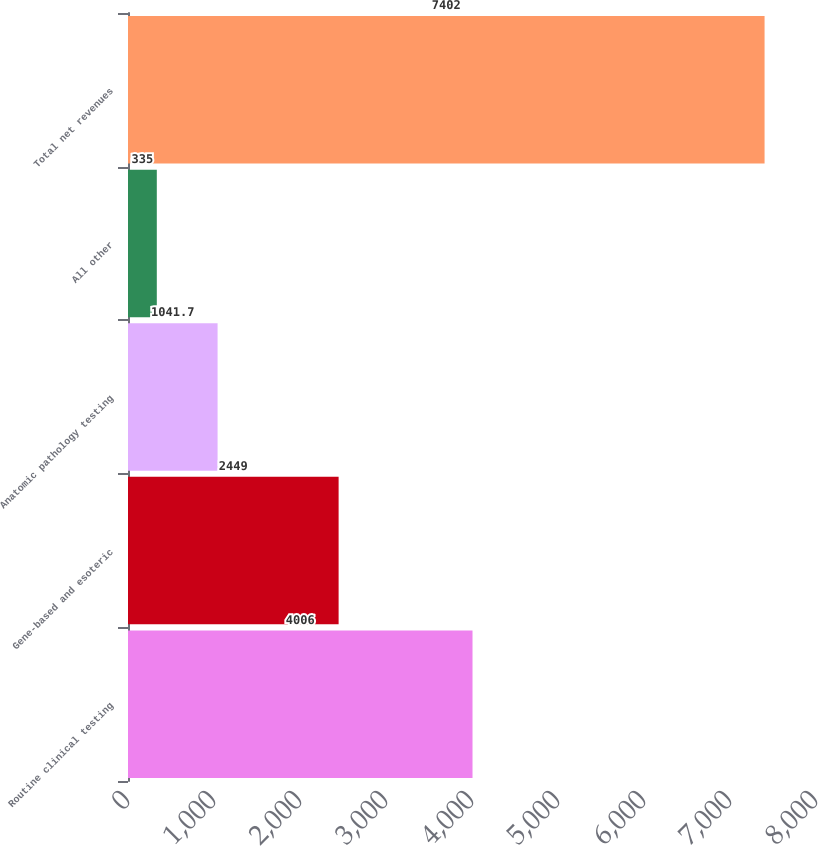<chart> <loc_0><loc_0><loc_500><loc_500><bar_chart><fcel>Routine clinical testing<fcel>Gene-based and esoteric<fcel>Anatomic pathology testing<fcel>All other<fcel>Total net revenues<nl><fcel>4006<fcel>2449<fcel>1041.7<fcel>335<fcel>7402<nl></chart> 